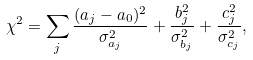Convert formula to latex. <formula><loc_0><loc_0><loc_500><loc_500>\chi ^ { 2 } = \sum _ { j } \frac { ( a _ { j } - a _ { 0 } ) ^ { 2 } } { \sigma _ { a _ { j } } ^ { 2 } } + \frac { b _ { j } ^ { 2 } } { \sigma _ { b _ { j } } ^ { 2 } } + \frac { c _ { j } ^ { 2 } } { \sigma _ { c _ { j } } ^ { 2 } } ,</formula> 